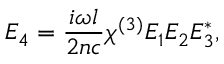Convert formula to latex. <formula><loc_0><loc_0><loc_500><loc_500>E _ { 4 } = { \frac { i \omega l } { 2 n c } } \chi ^ { ( 3 ) } E _ { 1 } E _ { 2 } E _ { 3 } ^ { * } ,</formula> 